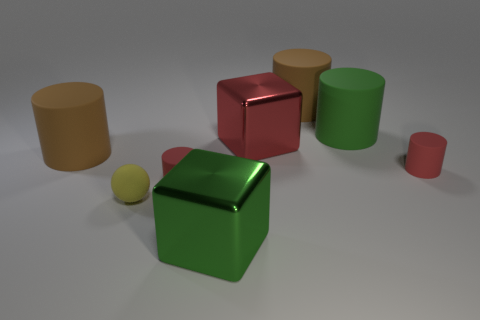What number of other objects are the same material as the tiny yellow sphere?
Ensure brevity in your answer.  5. Are there the same number of large metal objects to the right of the big red object and small blocks?
Offer a terse response. Yes. Is the size of the brown cylinder to the left of the yellow rubber thing the same as the red metallic thing?
Offer a terse response. Yes. There is a green metal thing; how many big green shiny cubes are in front of it?
Provide a short and direct response. 0. What is the material of the large thing that is in front of the green matte cylinder and right of the green metal object?
Your answer should be very brief. Metal. What number of big things are green matte objects or red metallic blocks?
Give a very brief answer. 2. How big is the red shiny block?
Ensure brevity in your answer.  Large. What is the shape of the yellow object?
Offer a very short reply. Sphere. Are there any other things that are the same shape as the tiny yellow object?
Keep it short and to the point. No. Are there fewer tiny spheres in front of the small yellow object than small gray matte blocks?
Offer a very short reply. No. 